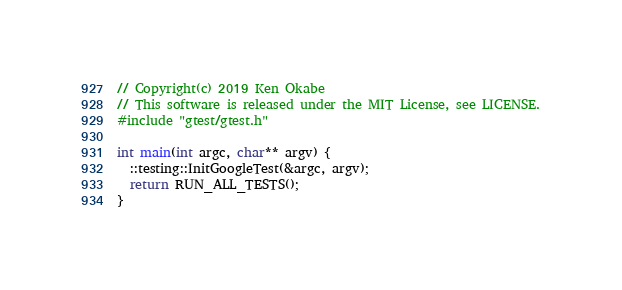<code> <loc_0><loc_0><loc_500><loc_500><_C++_>// Copyright(c) 2019 Ken Okabe
// This software is released under the MIT License, see LICENSE.
#include "gtest/gtest.h"

int main(int argc, char** argv) {
  ::testing::InitGoogleTest(&argc, argv);
  return RUN_ALL_TESTS();
}
</code> 